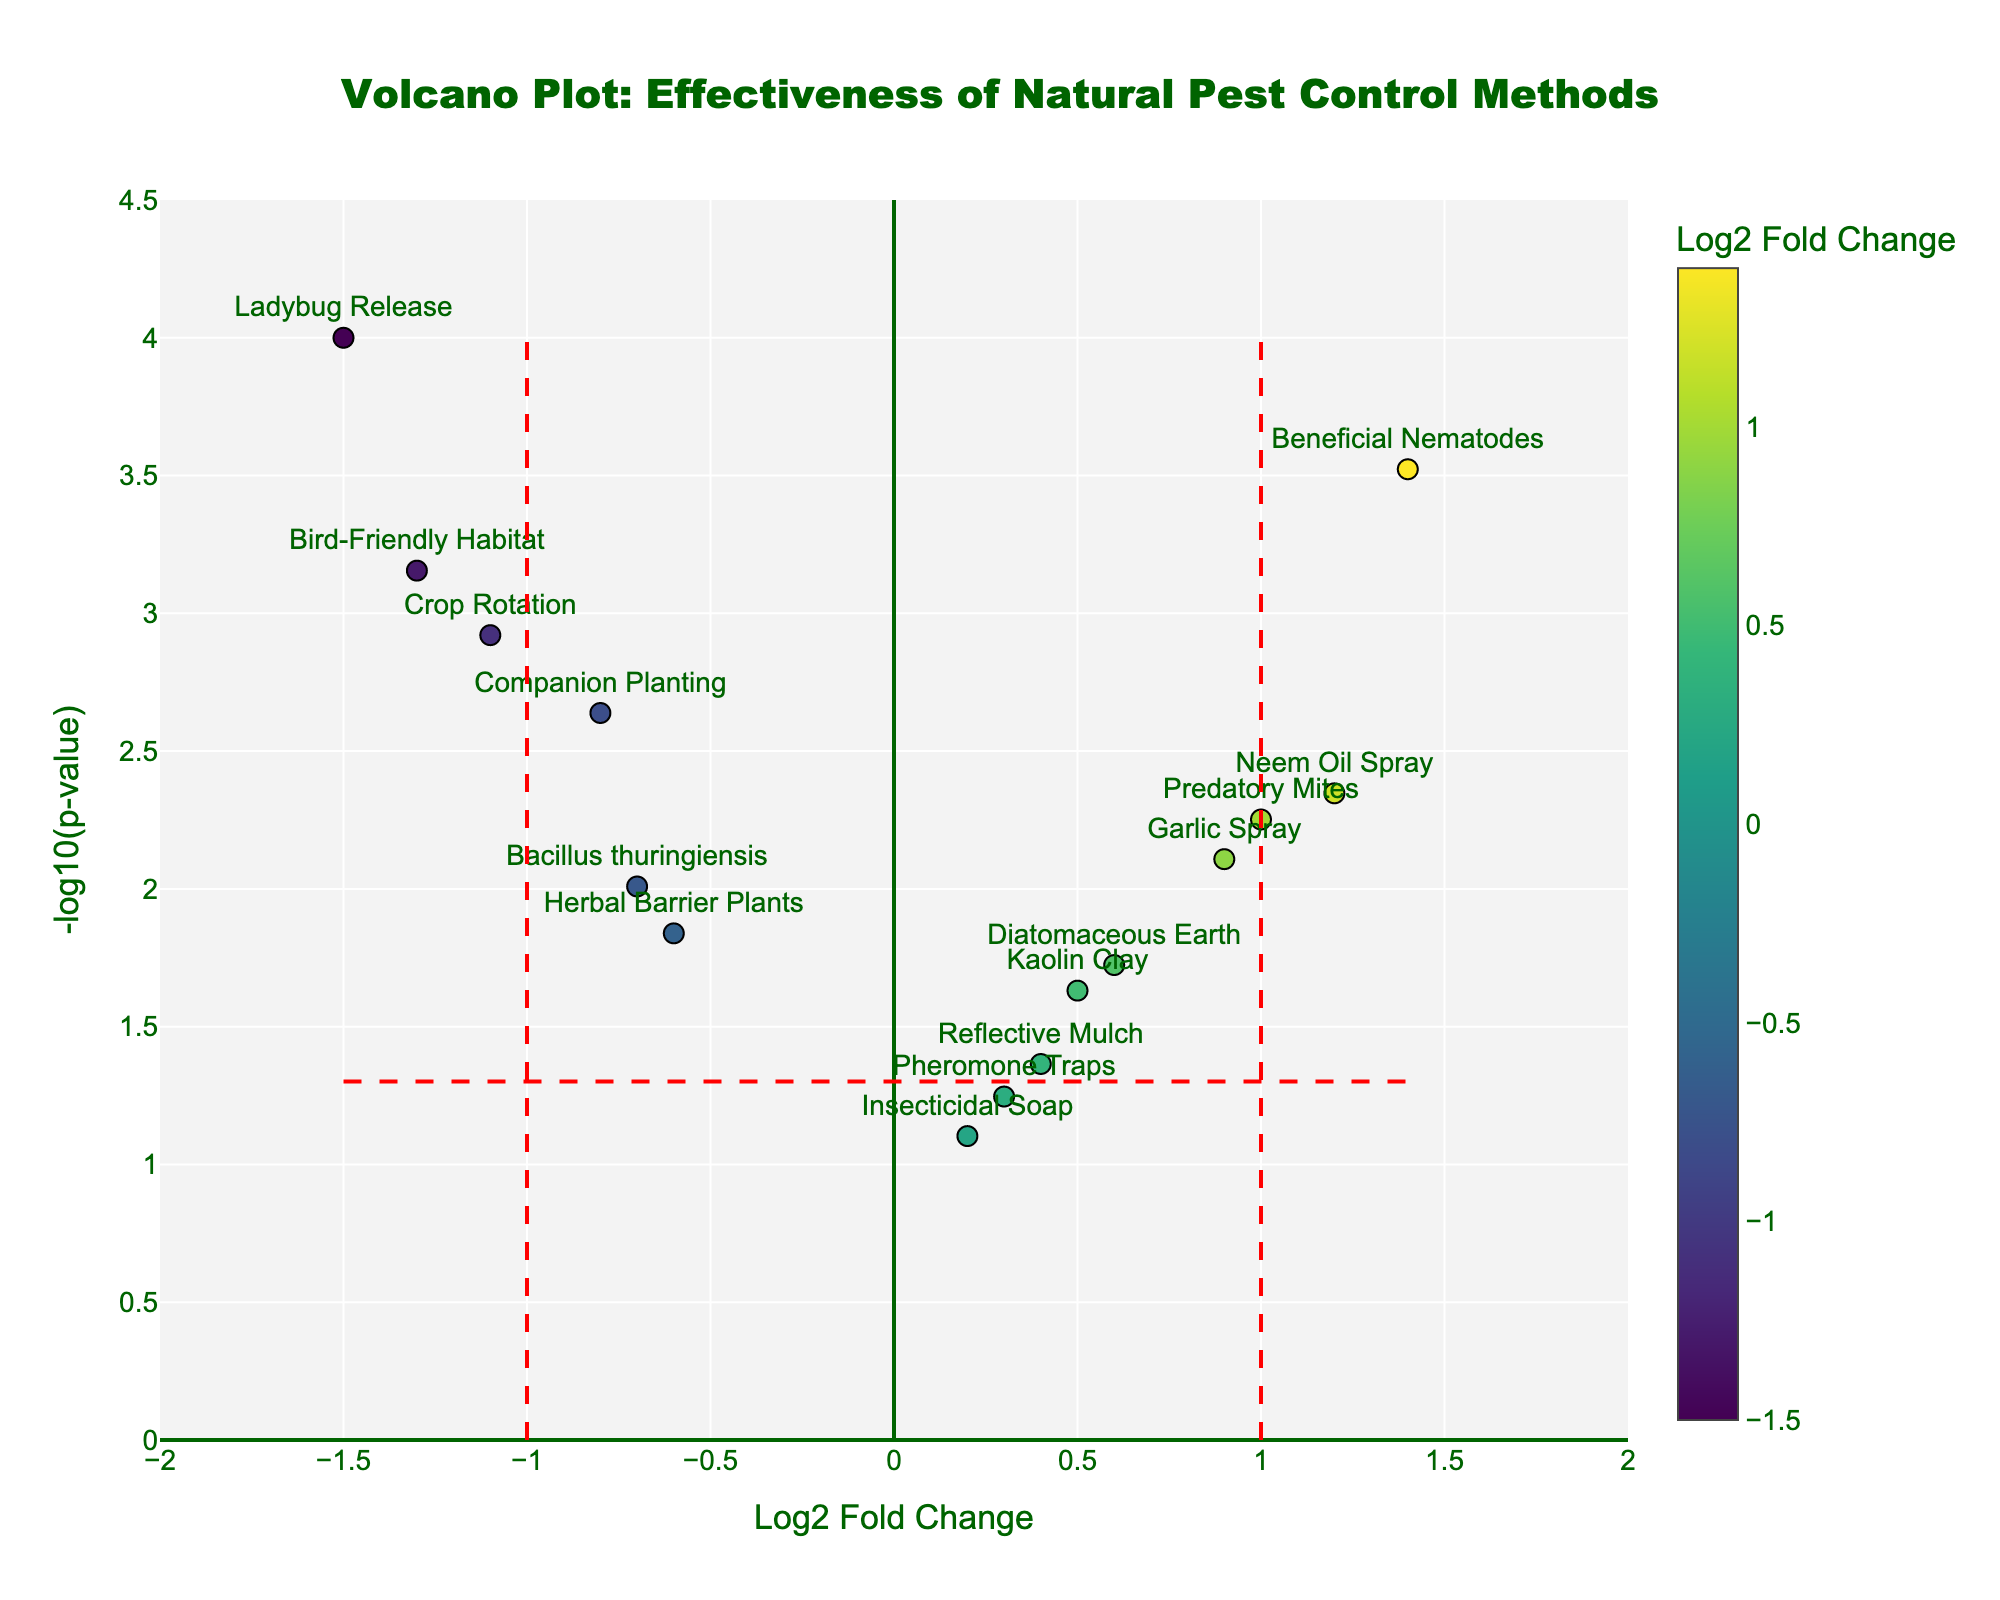What is the title of the plot? The title is usually found at the top of the plot. It summarizes what the plot is about and helps the reader understand the context without looking at the data. Here, the title is “Volcano Plot: Effectiveness of Natural Pest Control Methods”
Answer: Volcano Plot: Effectiveness of Natural Pest Control Methods Which method shows the highest log2 fold change? To find the method with the highest log2 fold change, look for the point that is farthest to the right on the x-axis. The method associated with this point is the one you are looking for.
Answer: Beneficial Nematodes How many methods have a log2 fold change greater than 0? To answer this, count the number of points that are situated to the right of the vertical line at log2 fold change = 0. Each point corresponds to a different method.
Answer: 7 What log2 fold change value does the vertical line on the right represent? The vertical lines are positioned at specific log2 fold change values and typically mark thresholds of interest. Here, the vertical line on the right is at a log2 fold change of 1.0.
Answer: 1.0 Which method has the lowest p-value? The method with the lowest p-value will be the one with the highest -log10(p-value), so look for the highest point on the y-axis.
Answer: Ladybug Release How many data points are above the horizontal line at -log10(p-value) = 1.3? The horizontal line at -log10(p-value) = 1.3 corresponds to p-value = 0.05. Count the points above this line to determine how many methods have a p-value less than 0.05.
Answer: 11 What is the log2 fold change and p-value of 'Reflective Mulch'? To find this, locate the 'Reflective Mulch' point on the plot and read off its x and y values, which correspond to the log2 fold change and -log10(p-value), respectively. Then, convert -log10(p-value) back to p-value. -log10(0.0432) ≈ 1.36.
Answer: 0.4, 0.0432 Which method has a significant negative impact on crop yield (log2 fold change < -1) with a p-value < 0.01? Look for methods with log2 fold change values less than -1 and then check their p-values. Points to the left of the vertical line at -1 with high y-values indicate significant negative impacts.
Answer: Ladybug Release, Bird-Friendly Habitat, Crop Rotation Compare the log2 fold change of 'Neem Oil Spray' and 'Garlic Spray'. Which one is higher? Find the points corresponding to 'Neem Oil Spray' and 'Garlic Spray' on the x-axis. Compare their x-values directly to see which is higher.
Answer: Neem Oil Spray What can be inferred if a method has a log2 fold change near zero and a high p-value? If the log2 fold change is near zero, it indicates no substantial effect on crop yield. A high p-value (low -log10(p-value)) suggests the results are not statistically significant. For example, 'Insecticidal Soap' has a log2 fold change close to zero and a higher p-value.
Answer: The method likely has no significant impact on crop yield 